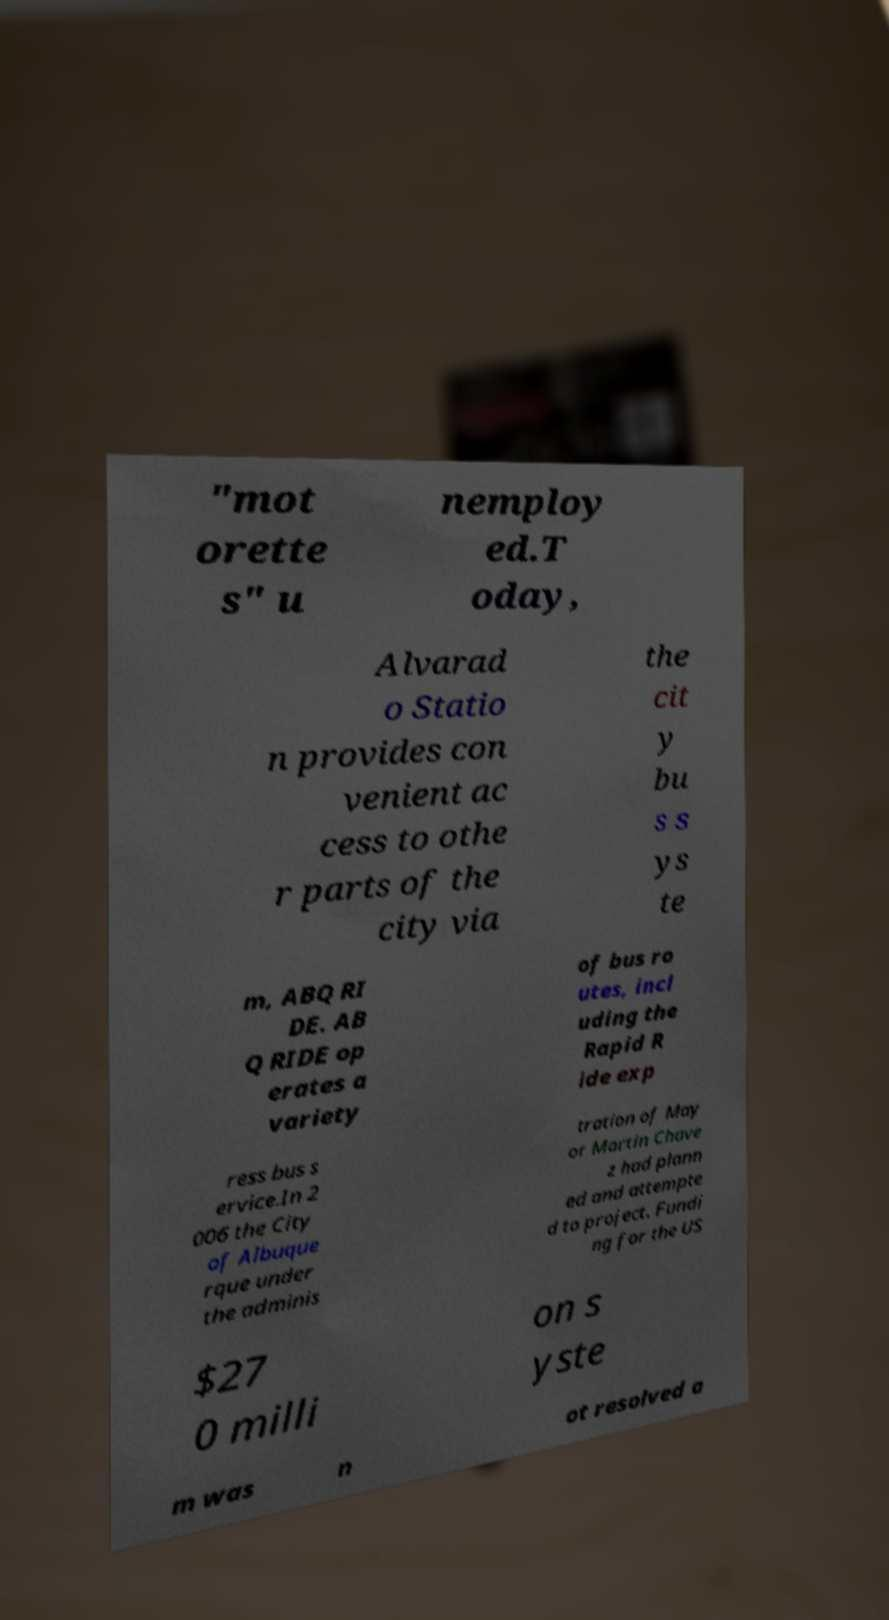Could you assist in decoding the text presented in this image and type it out clearly? "mot orette s" u nemploy ed.T oday, Alvarad o Statio n provides con venient ac cess to othe r parts of the city via the cit y bu s s ys te m, ABQ RI DE. AB Q RIDE op erates a variety of bus ro utes, incl uding the Rapid R ide exp ress bus s ervice.In 2 006 the City of Albuque rque under the adminis tration of May or Martin Chave z had plann ed and attempte d to project. Fundi ng for the US $27 0 milli on s yste m was n ot resolved a 